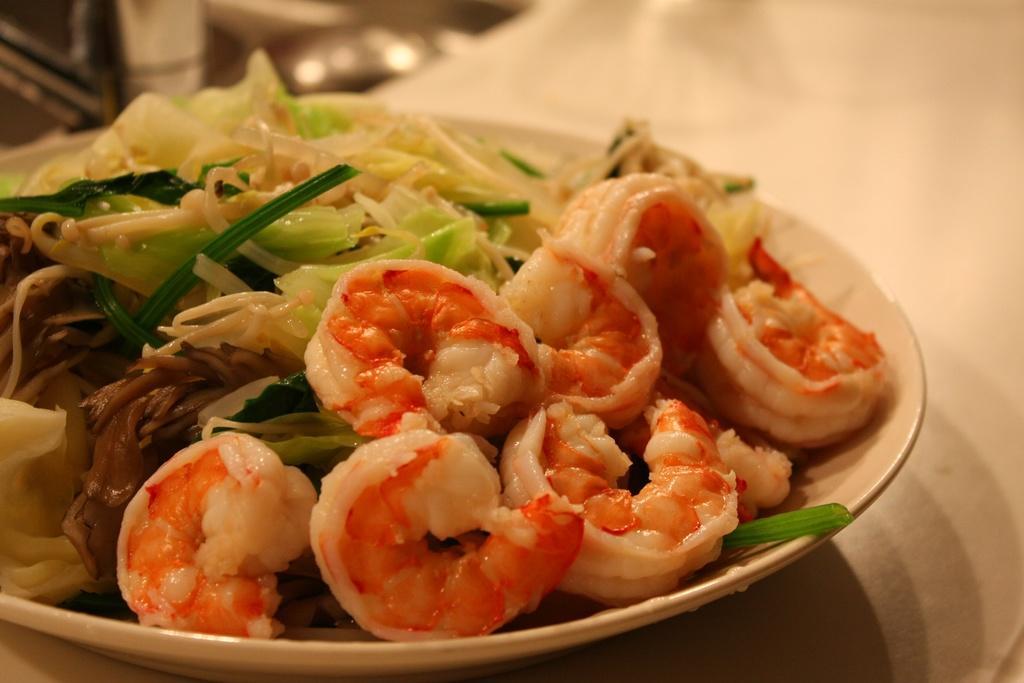Could you give a brief overview of what you see in this image? In the center of the image there is a plate with food items in it. 